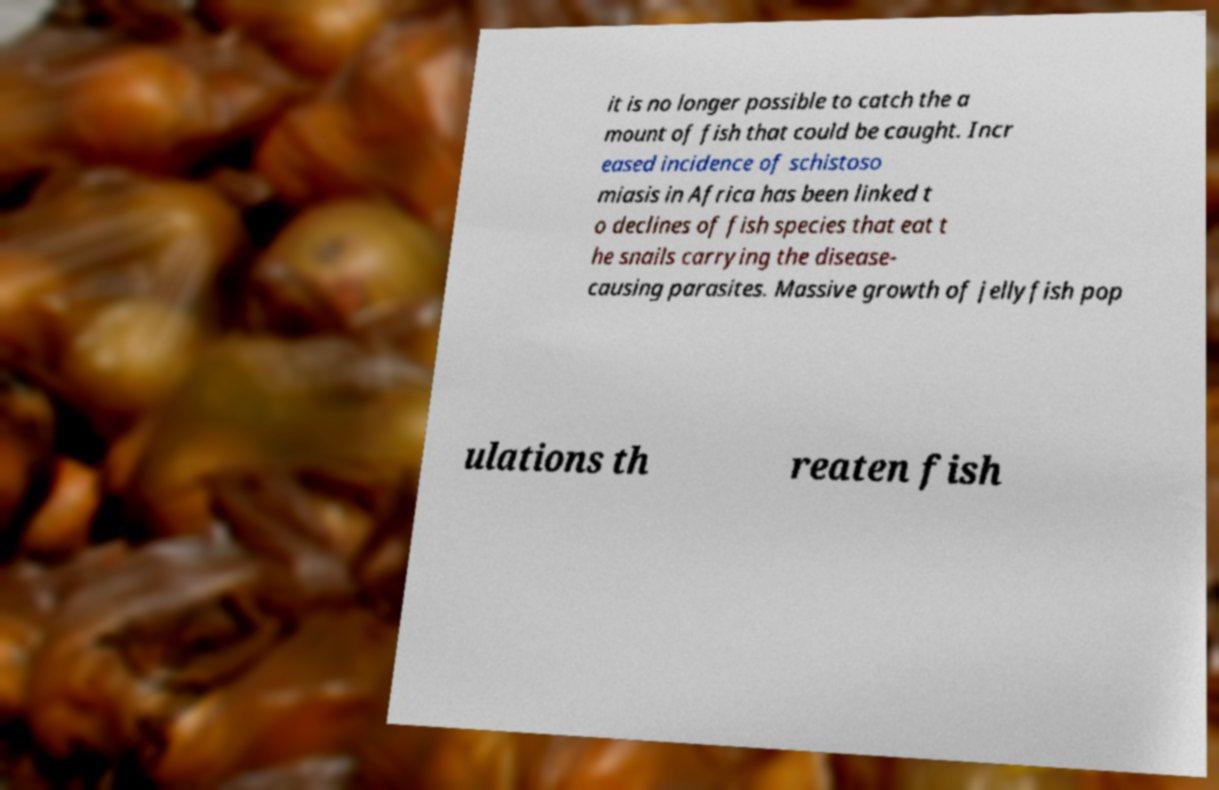What messages or text are displayed in this image? I need them in a readable, typed format. it is no longer possible to catch the a mount of fish that could be caught. Incr eased incidence of schistoso miasis in Africa has been linked t o declines of fish species that eat t he snails carrying the disease- causing parasites. Massive growth of jellyfish pop ulations th reaten fish 